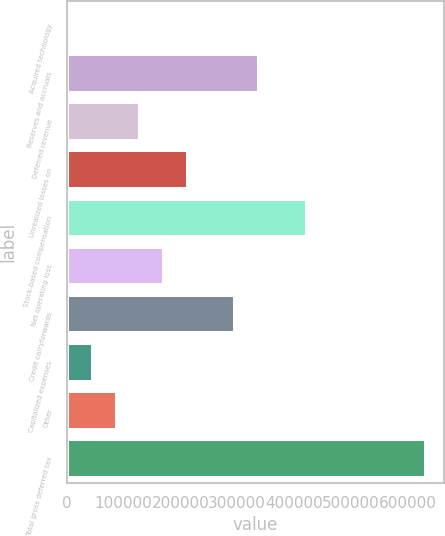Convert chart to OTSL. <chart><loc_0><loc_0><loc_500><loc_500><bar_chart><fcel>Acquired technology<fcel>Reserves and accruals<fcel>Deferred revenue<fcel>Unrealized losses on<fcel>Stock-based compensation<fcel>Net operating loss<fcel>Credit carryforwards<fcel>Capitalized expenses<fcel>Other<fcel>Total gross deferred tax<nl><fcel>3890<fcel>338633<fcel>129419<fcel>213104<fcel>422319<fcel>171262<fcel>296790<fcel>45732.9<fcel>87575.8<fcel>631534<nl></chart> 